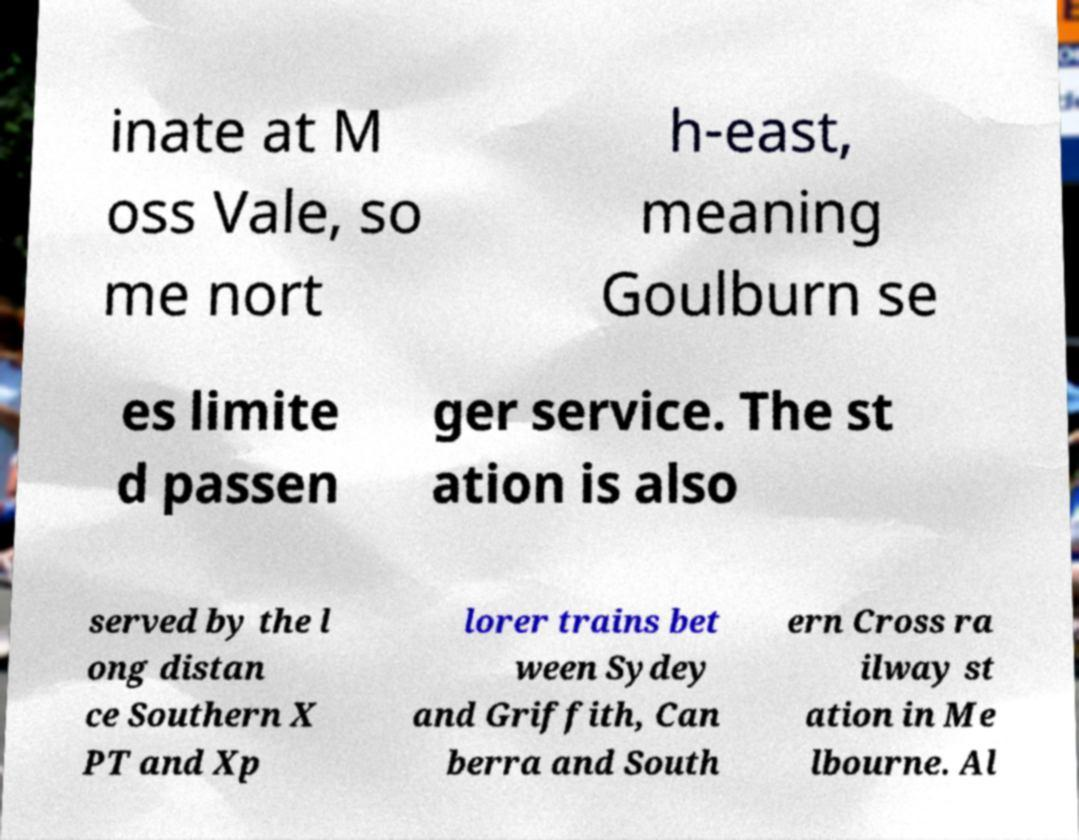Please identify and transcribe the text found in this image. inate at M oss Vale, so me nort h-east, meaning Goulburn se es limite d passen ger service. The st ation is also served by the l ong distan ce Southern X PT and Xp lorer trains bet ween Sydey and Griffith, Can berra and South ern Cross ra ilway st ation in Me lbourne. Al 